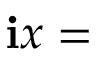Convert formula to latex. <formula><loc_0><loc_0><loc_500><loc_500>i x =</formula> 